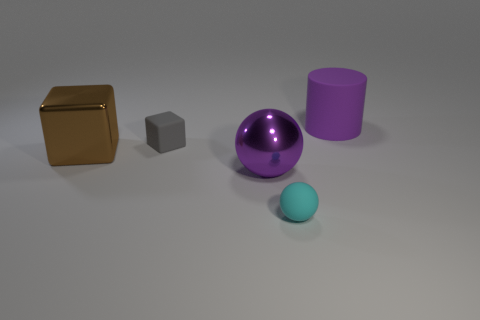Are there any patterns or textures visible on the objects? The objects appear to have smooth surfaces without any distinct patterns or textures. 